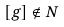<formula> <loc_0><loc_0><loc_500><loc_500>[ g ] \notin N</formula> 